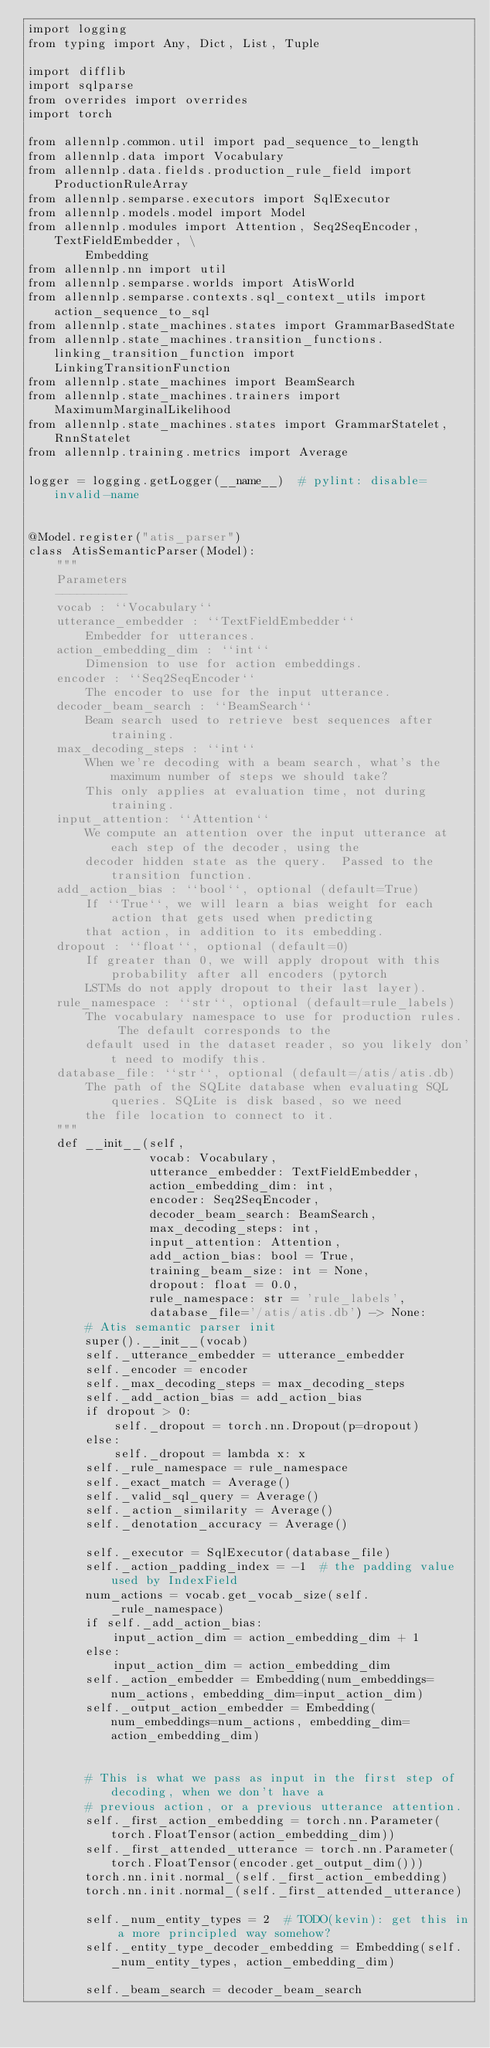Convert code to text. <code><loc_0><loc_0><loc_500><loc_500><_Python_>import logging
from typing import Any, Dict, List, Tuple

import difflib
import sqlparse
from overrides import overrides
import torch

from allennlp.common.util import pad_sequence_to_length
from allennlp.data import Vocabulary
from allennlp.data.fields.production_rule_field import ProductionRuleArray
from allennlp.semparse.executors import SqlExecutor
from allennlp.models.model import Model
from allennlp.modules import Attention, Seq2SeqEncoder, TextFieldEmbedder, \
        Embedding
from allennlp.nn import util
from allennlp.semparse.worlds import AtisWorld
from allennlp.semparse.contexts.sql_context_utils import action_sequence_to_sql
from allennlp.state_machines.states import GrammarBasedState
from allennlp.state_machines.transition_functions.linking_transition_function import LinkingTransitionFunction
from allennlp.state_machines import BeamSearch
from allennlp.state_machines.trainers import MaximumMarginalLikelihood
from allennlp.state_machines.states import GrammarStatelet, RnnStatelet
from allennlp.training.metrics import Average

logger = logging.getLogger(__name__)  # pylint: disable=invalid-name


@Model.register("atis_parser")
class AtisSemanticParser(Model):
    """
    Parameters
    ----------
    vocab : ``Vocabulary``
    utterance_embedder : ``TextFieldEmbedder``
        Embedder for utterances.
    action_embedding_dim : ``int``
        Dimension to use for action embeddings.
    encoder : ``Seq2SeqEncoder``
        The encoder to use for the input utterance.
    decoder_beam_search : ``BeamSearch``
        Beam search used to retrieve best sequences after training.
    max_decoding_steps : ``int``
        When we're decoding with a beam search, what's the maximum number of steps we should take?
        This only applies at evaluation time, not during training.
    input_attention: ``Attention``
        We compute an attention over the input utterance at each step of the decoder, using the
        decoder hidden state as the query.  Passed to the transition function.
    add_action_bias : ``bool``, optional (default=True)
        If ``True``, we will learn a bias weight for each action that gets used when predicting
        that action, in addition to its embedding.
    dropout : ``float``, optional (default=0)
        If greater than 0, we will apply dropout with this probability after all encoders (pytorch
        LSTMs do not apply dropout to their last layer).
    rule_namespace : ``str``, optional (default=rule_labels)
        The vocabulary namespace to use for production rules.  The default corresponds to the
        default used in the dataset reader, so you likely don't need to modify this.
    database_file: ``str``, optional (default=/atis/atis.db)
        The path of the SQLite database when evaluating SQL queries. SQLite is disk based, so we need
        the file location to connect to it.
    """
    def __init__(self,
                 vocab: Vocabulary,
                 utterance_embedder: TextFieldEmbedder,
                 action_embedding_dim: int,
                 encoder: Seq2SeqEncoder,
                 decoder_beam_search: BeamSearch,
                 max_decoding_steps: int,
                 input_attention: Attention,
                 add_action_bias: bool = True,
                 training_beam_size: int = None,
                 dropout: float = 0.0,
                 rule_namespace: str = 'rule_labels',
                 database_file='/atis/atis.db') -> None:
        # Atis semantic parser init
        super().__init__(vocab)
        self._utterance_embedder = utterance_embedder
        self._encoder = encoder
        self._max_decoding_steps = max_decoding_steps
        self._add_action_bias = add_action_bias
        if dropout > 0:
            self._dropout = torch.nn.Dropout(p=dropout)
        else:
            self._dropout = lambda x: x
        self._rule_namespace = rule_namespace
        self._exact_match = Average()
        self._valid_sql_query = Average()
        self._action_similarity = Average()
        self._denotation_accuracy = Average()

        self._executor = SqlExecutor(database_file)
        self._action_padding_index = -1  # the padding value used by IndexField
        num_actions = vocab.get_vocab_size(self._rule_namespace)
        if self._add_action_bias:
            input_action_dim = action_embedding_dim + 1
        else:
            input_action_dim = action_embedding_dim
        self._action_embedder = Embedding(num_embeddings=num_actions, embedding_dim=input_action_dim)
        self._output_action_embedder = Embedding(num_embeddings=num_actions, embedding_dim=action_embedding_dim)


        # This is what we pass as input in the first step of decoding, when we don't have a
        # previous action, or a previous utterance attention.
        self._first_action_embedding = torch.nn.Parameter(torch.FloatTensor(action_embedding_dim))
        self._first_attended_utterance = torch.nn.Parameter(torch.FloatTensor(encoder.get_output_dim()))
        torch.nn.init.normal_(self._first_action_embedding)
        torch.nn.init.normal_(self._first_attended_utterance)

        self._num_entity_types = 2  # TODO(kevin): get this in a more principled way somehow?
        self._entity_type_decoder_embedding = Embedding(self._num_entity_types, action_embedding_dim)

        self._beam_search = decoder_beam_search</code> 